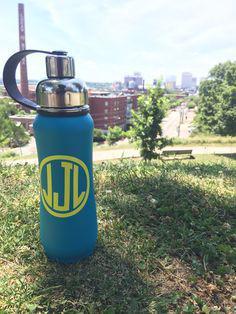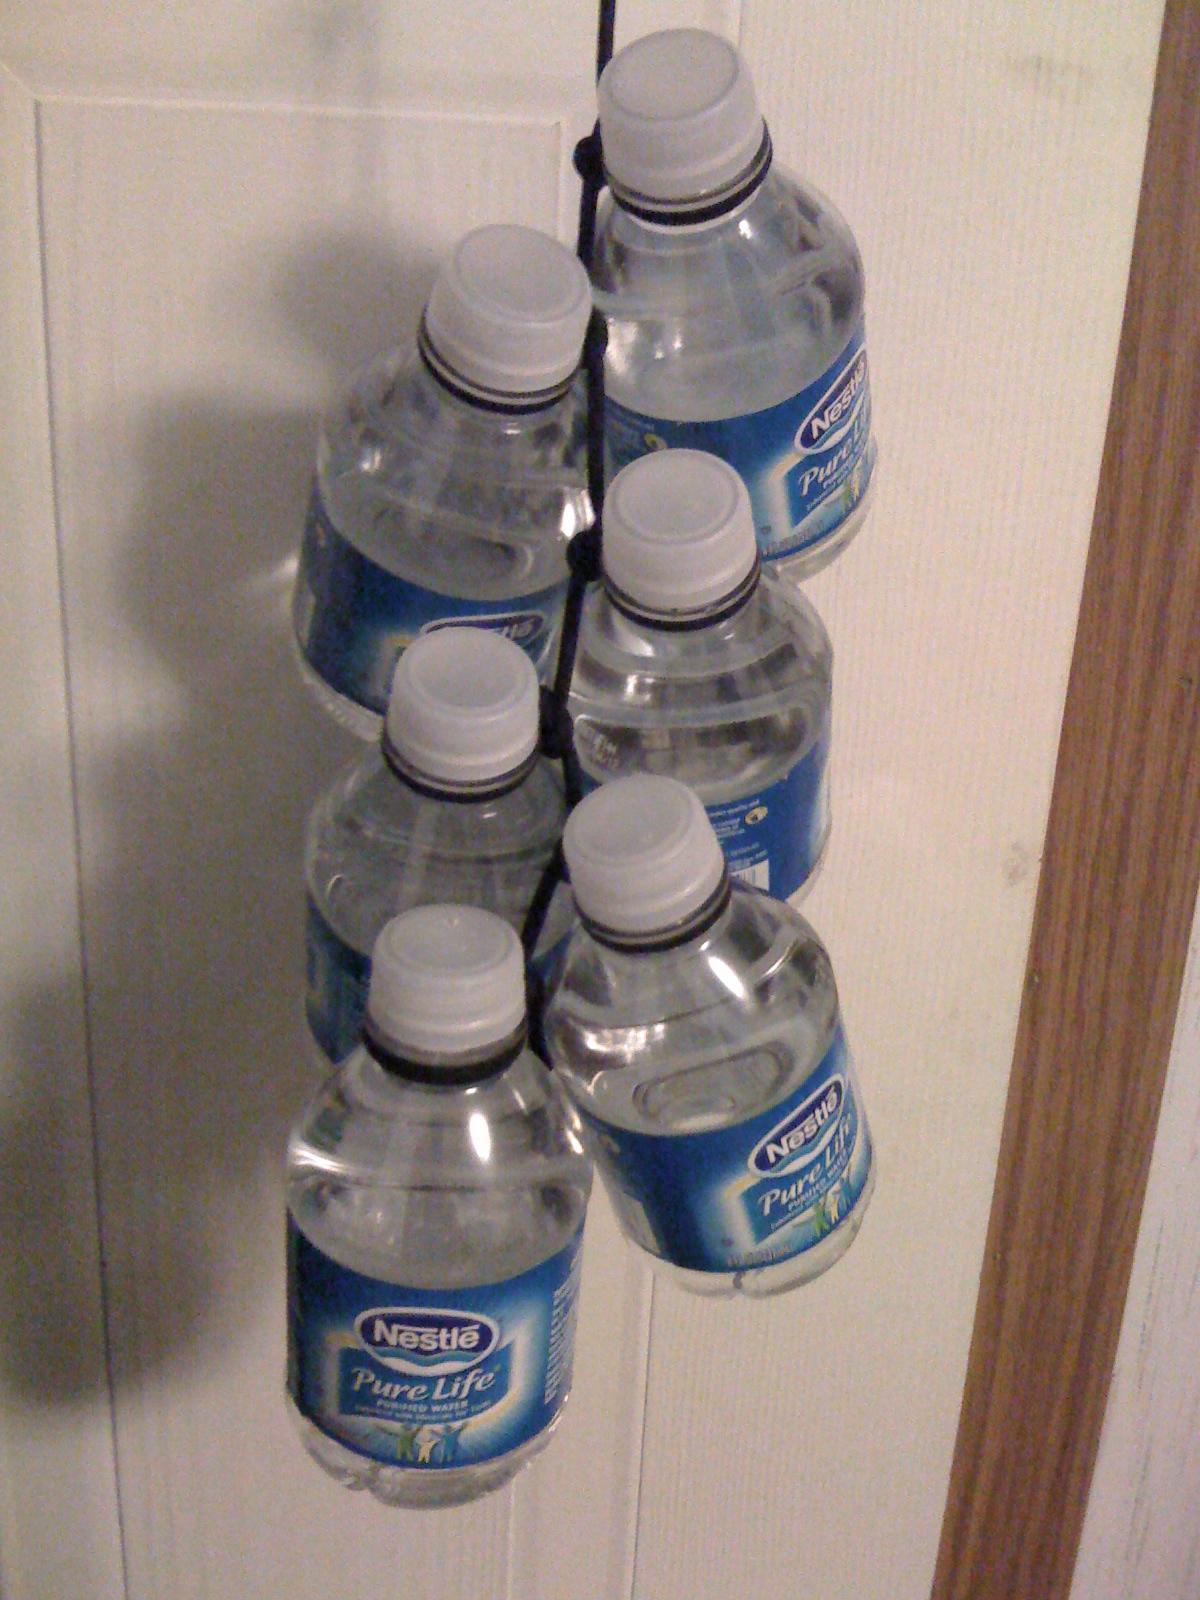The first image is the image on the left, the second image is the image on the right. For the images shown, is this caption "There is at least one disposable water bottle with a white cap." true? Answer yes or no. Yes. 